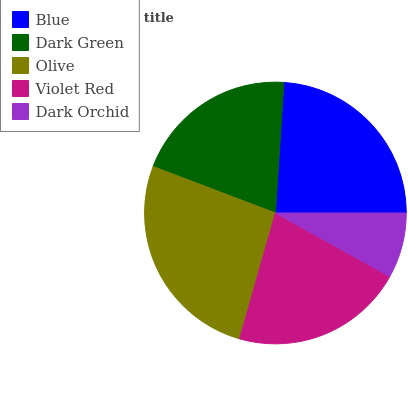Is Dark Orchid the minimum?
Answer yes or no. Yes. Is Olive the maximum?
Answer yes or no. Yes. Is Dark Green the minimum?
Answer yes or no. No. Is Dark Green the maximum?
Answer yes or no. No. Is Blue greater than Dark Green?
Answer yes or no. Yes. Is Dark Green less than Blue?
Answer yes or no. Yes. Is Dark Green greater than Blue?
Answer yes or no. No. Is Blue less than Dark Green?
Answer yes or no. No. Is Violet Red the high median?
Answer yes or no. Yes. Is Violet Red the low median?
Answer yes or no. Yes. Is Dark Green the high median?
Answer yes or no. No. Is Dark Green the low median?
Answer yes or no. No. 